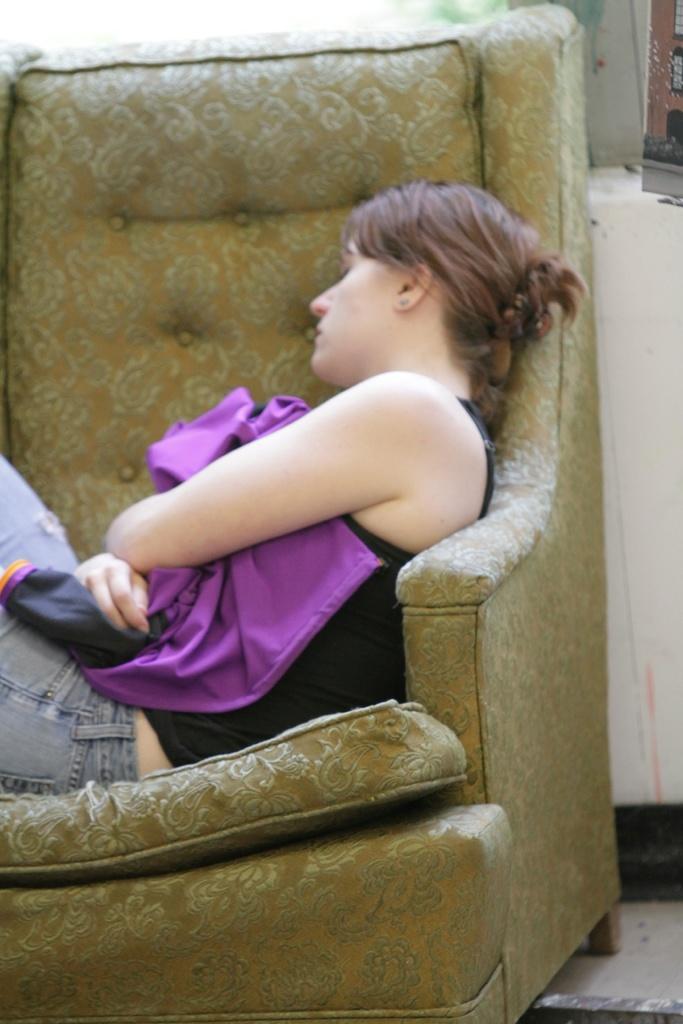Can you describe this image briefly? In this picture we can see a woman sleeping on a sofa. This is a wall painted with cream colour. This is a floor. 